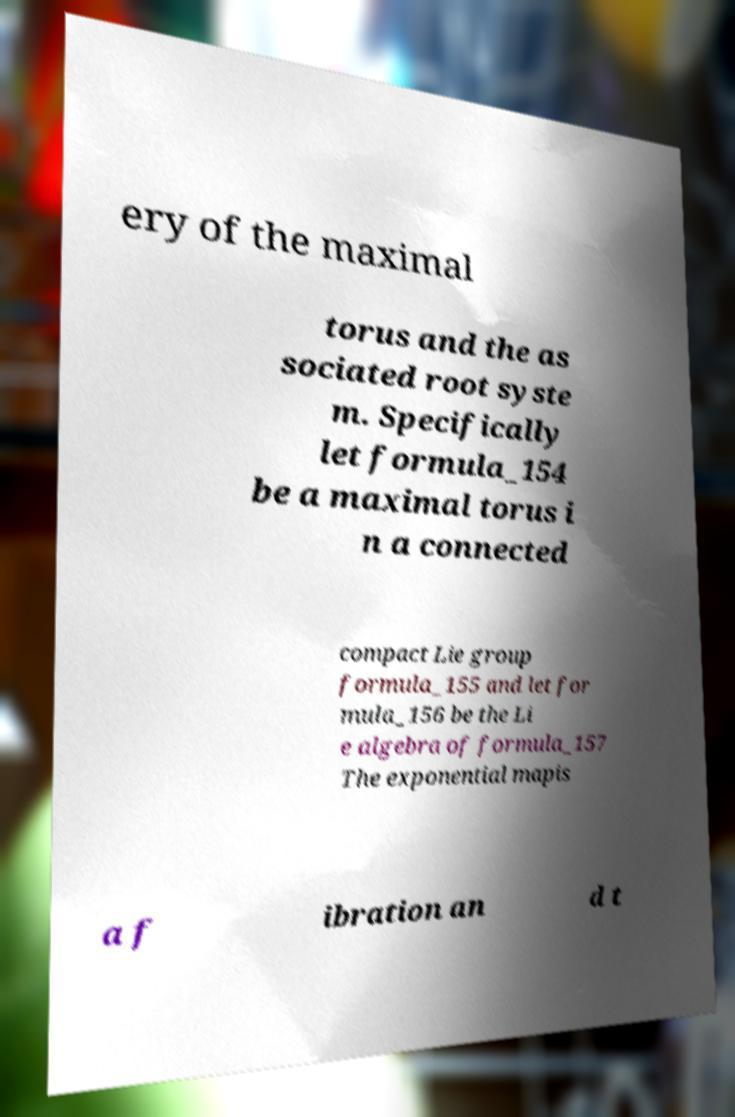Could you extract and type out the text from this image? ery of the maximal torus and the as sociated root syste m. Specifically let formula_154 be a maximal torus i n a connected compact Lie group formula_155 and let for mula_156 be the Li e algebra of formula_157 The exponential mapis a f ibration an d t 